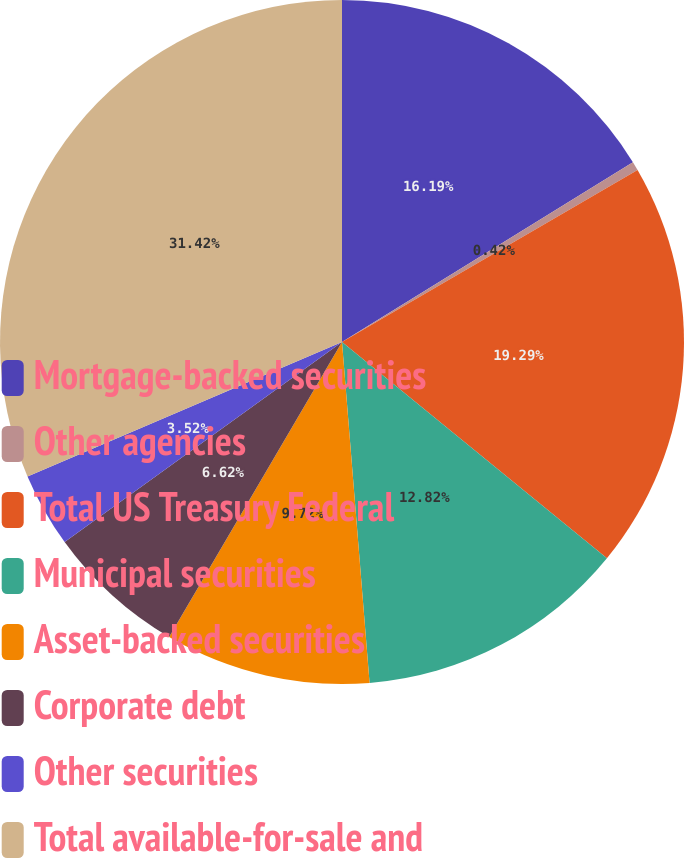<chart> <loc_0><loc_0><loc_500><loc_500><pie_chart><fcel>Mortgage-backed securities<fcel>Other agencies<fcel>Total US Treasury Federal<fcel>Municipal securities<fcel>Asset-backed securities<fcel>Corporate debt<fcel>Other securities<fcel>Total available-for-sale and<nl><fcel>16.19%<fcel>0.42%<fcel>19.29%<fcel>12.82%<fcel>9.72%<fcel>6.62%<fcel>3.52%<fcel>31.43%<nl></chart> 